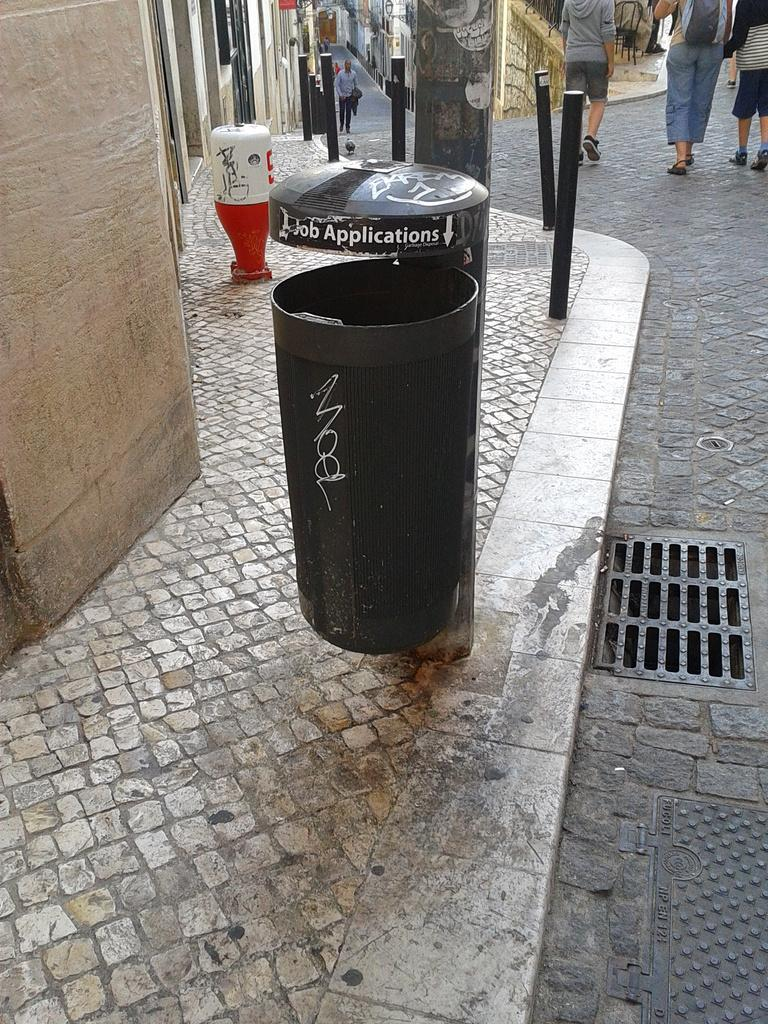<image>
Give a short and clear explanation of the subsequent image. A black bin has an arrow pointing down with the words job applications next to it. 